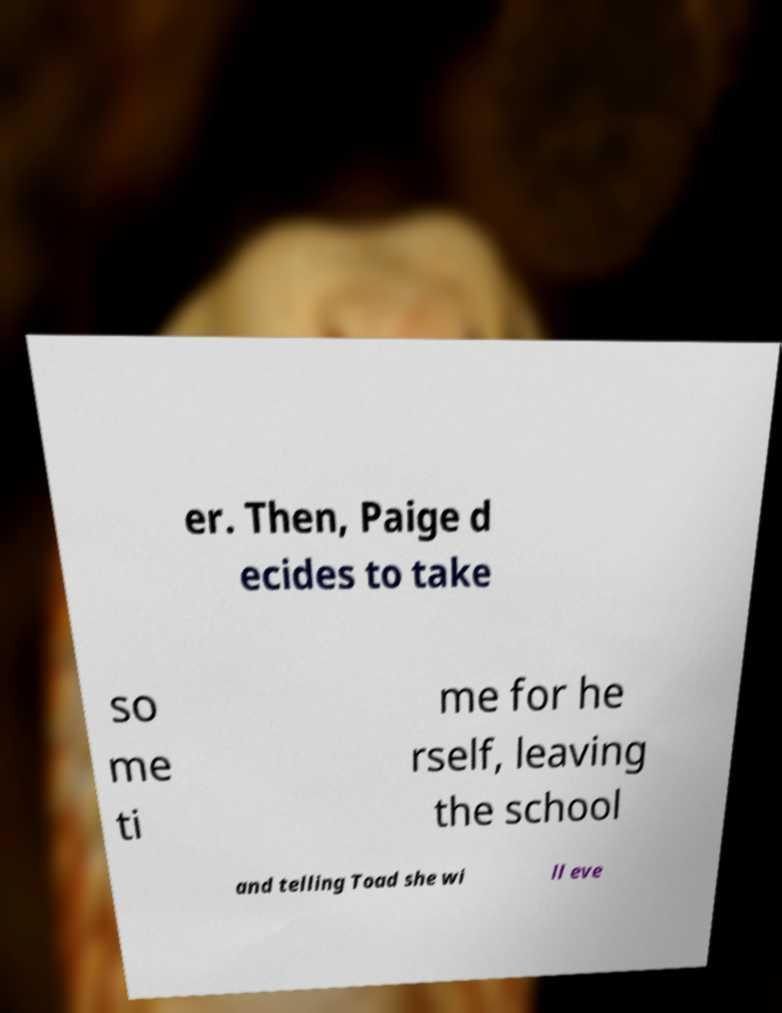Can you accurately transcribe the text from the provided image for me? er. Then, Paige d ecides to take so me ti me for he rself, leaving the school and telling Toad she wi ll eve 